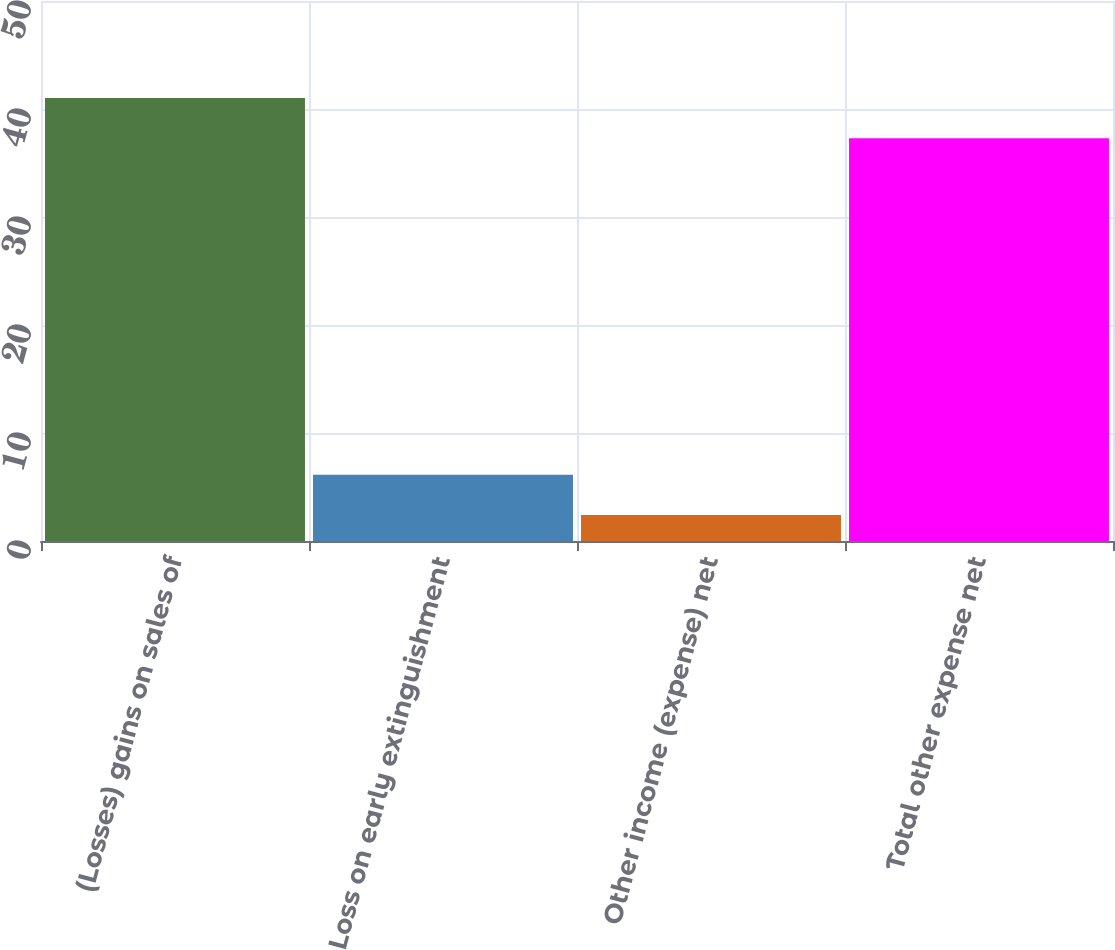Convert chart to OTSL. <chart><loc_0><loc_0><loc_500><loc_500><bar_chart><fcel>(Losses) gains on sales of<fcel>Loss on early extinguishment<fcel>Other income (expense) net<fcel>Total other expense net<nl><fcel>41.03<fcel>6.13<fcel>2.4<fcel>37.3<nl></chart> 